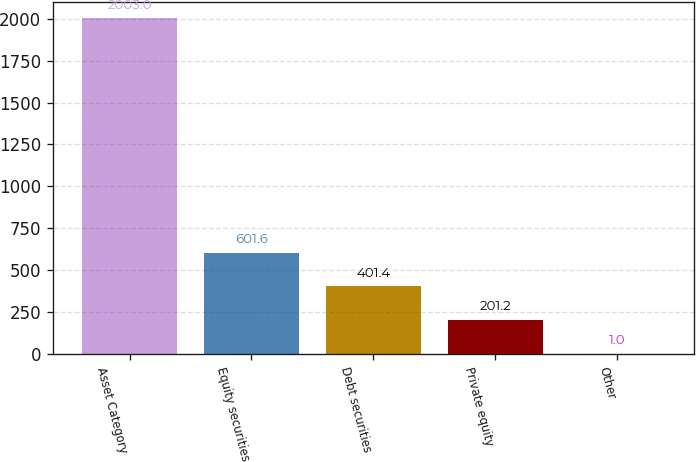Convert chart to OTSL. <chart><loc_0><loc_0><loc_500><loc_500><bar_chart><fcel>Asset Category<fcel>Equity securities<fcel>Debt securities<fcel>Private equity<fcel>Other<nl><fcel>2003<fcel>601.6<fcel>401.4<fcel>201.2<fcel>1<nl></chart> 